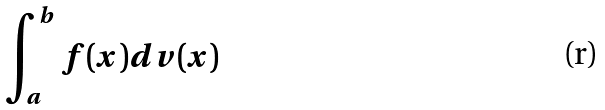<formula> <loc_0><loc_0><loc_500><loc_500>\int _ { a } ^ { b } f ( x ) d v ( x )</formula> 